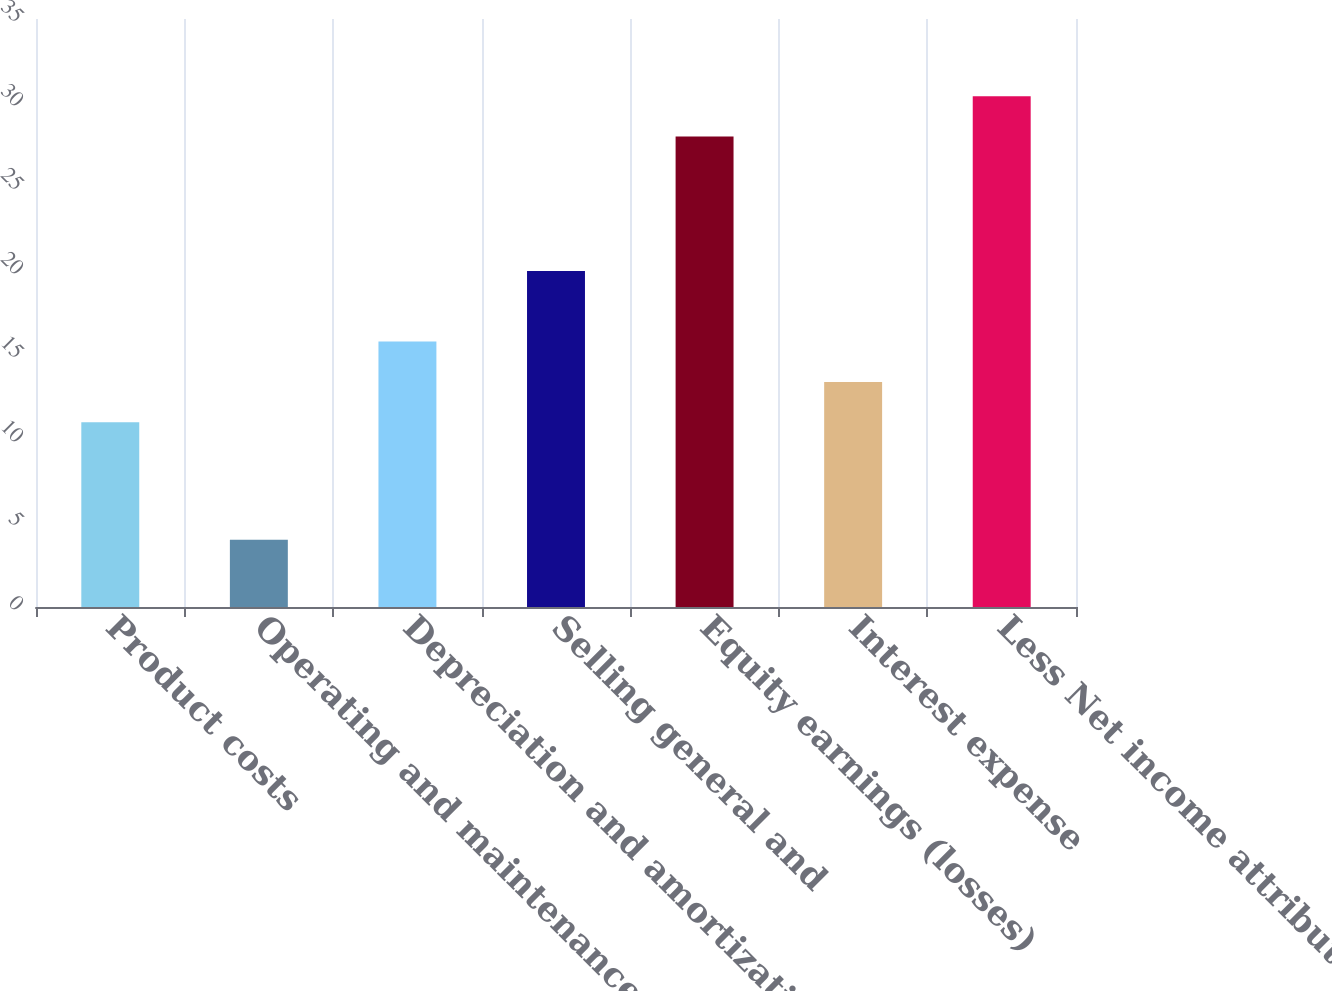Convert chart. <chart><loc_0><loc_0><loc_500><loc_500><bar_chart><fcel>Product costs<fcel>Operating and maintenance<fcel>Depreciation and amortization<fcel>Selling general and<fcel>Equity earnings (losses)<fcel>Interest expense<fcel>Less Net income attributable<nl><fcel>11<fcel>4<fcel>15.8<fcel>20<fcel>28<fcel>13.4<fcel>30.4<nl></chart> 